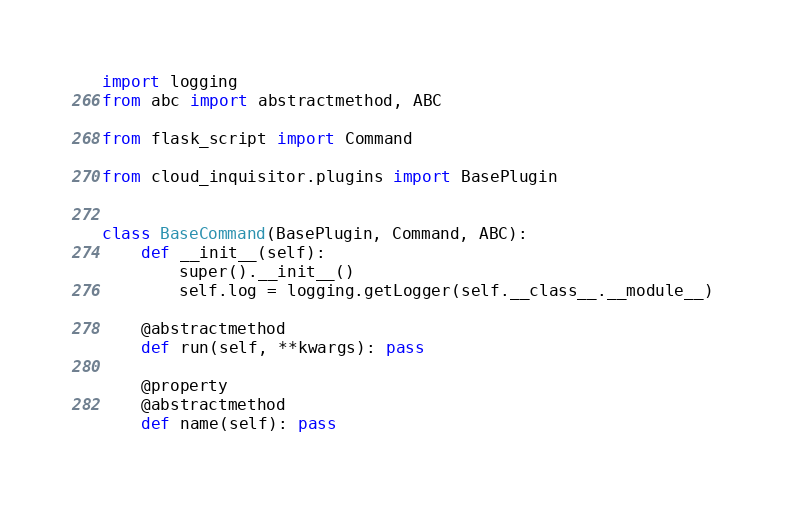<code> <loc_0><loc_0><loc_500><loc_500><_Python_>import logging
from abc import abstractmethod, ABC

from flask_script import Command

from cloud_inquisitor.plugins import BasePlugin


class BaseCommand(BasePlugin, Command, ABC):
    def __init__(self):
        super().__init__()
        self.log = logging.getLogger(self.__class__.__module__)

    @abstractmethod
    def run(self, **kwargs): pass

    @property
    @abstractmethod
    def name(self): pass
</code> 